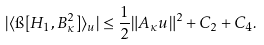Convert formula to latex. <formula><loc_0><loc_0><loc_500><loc_500>| \langle \i [ H _ { 1 } , B _ { \kappa } ^ { 2 } ] \rangle _ { u } | \leq \frac { 1 } { 2 } \| A _ { \kappa } u \| ^ { 2 } + C _ { 2 } + C _ { 4 } .</formula> 